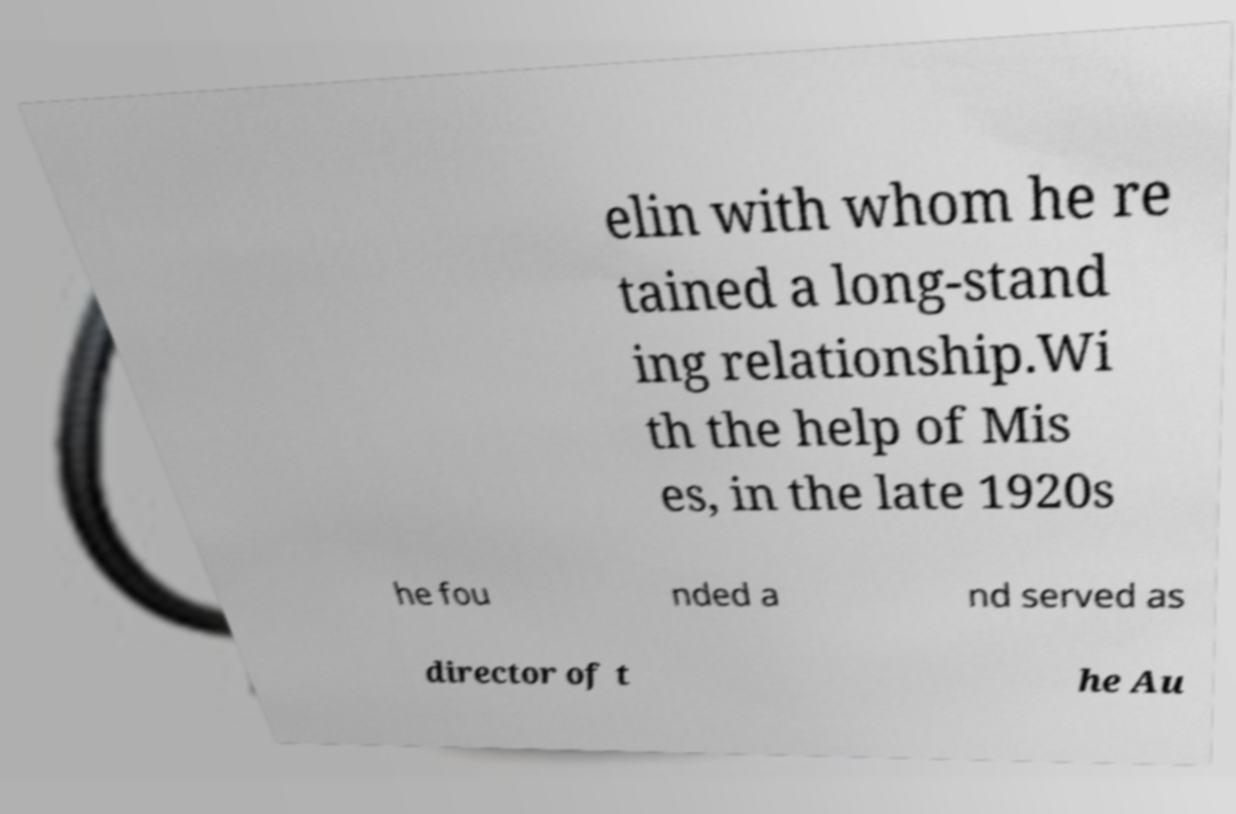For documentation purposes, I need the text within this image transcribed. Could you provide that? elin with whom he re tained a long-stand ing relationship.Wi th the help of Mis es, in the late 1920s he fou nded a nd served as director of t he Au 